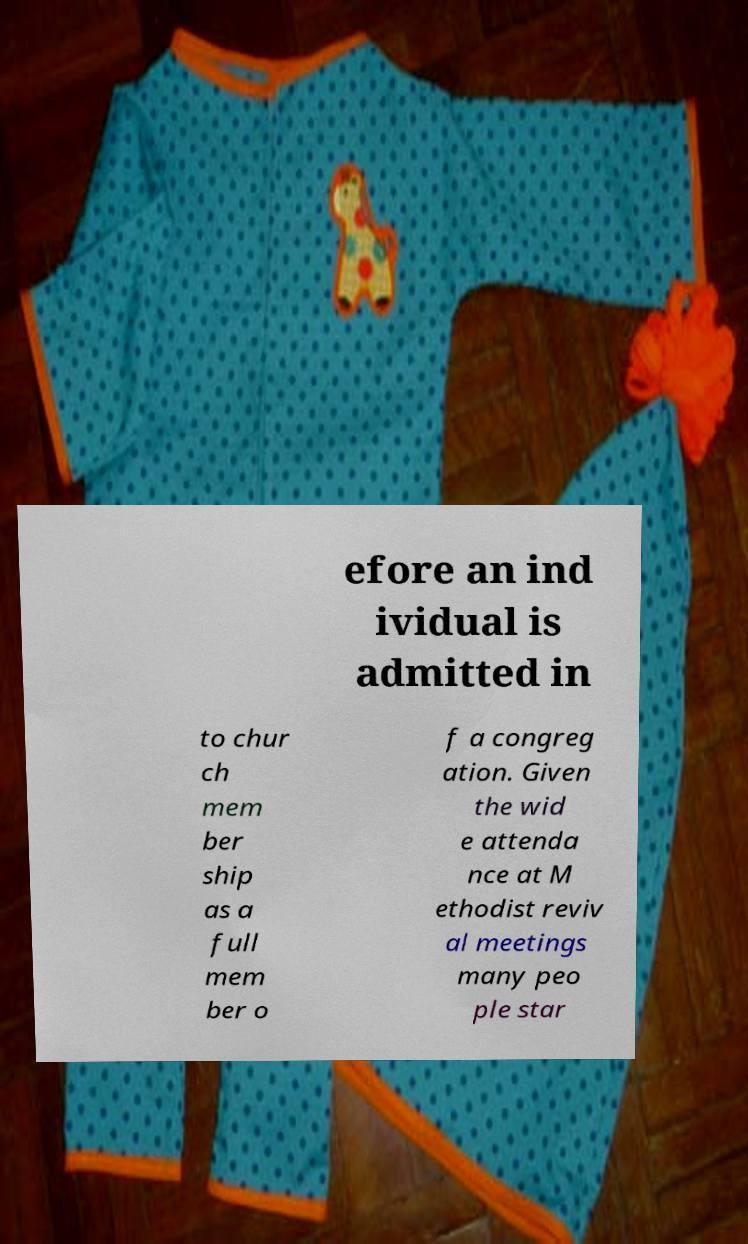Could you extract and type out the text from this image? efore an ind ividual is admitted in to chur ch mem ber ship as a full mem ber o f a congreg ation. Given the wid e attenda nce at M ethodist reviv al meetings many peo ple star 